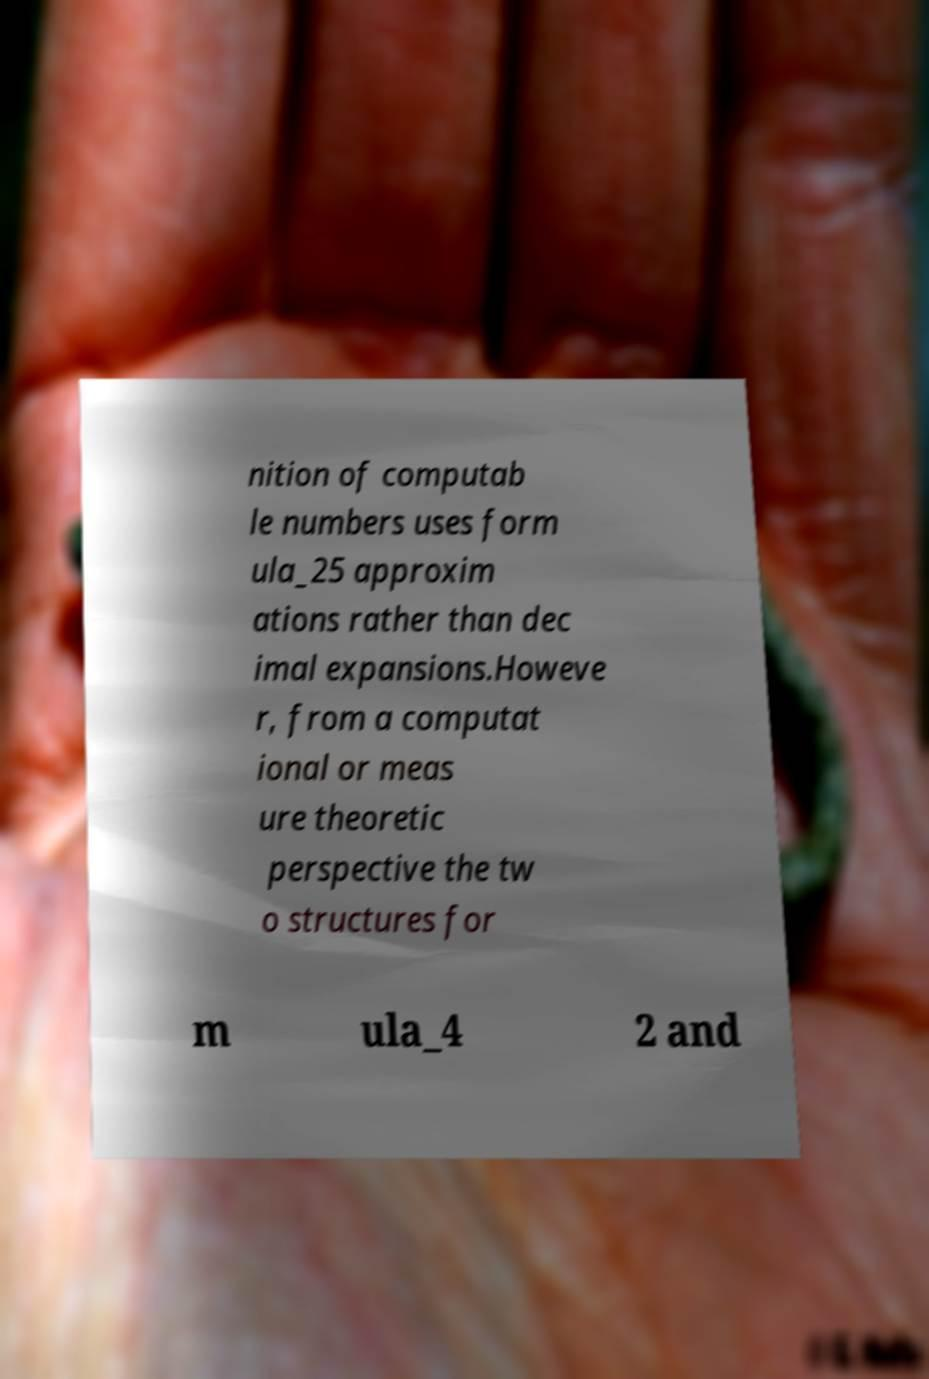For documentation purposes, I need the text within this image transcribed. Could you provide that? nition of computab le numbers uses form ula_25 approxim ations rather than dec imal expansions.Howeve r, from a computat ional or meas ure theoretic perspective the tw o structures for m ula_4 2 and 